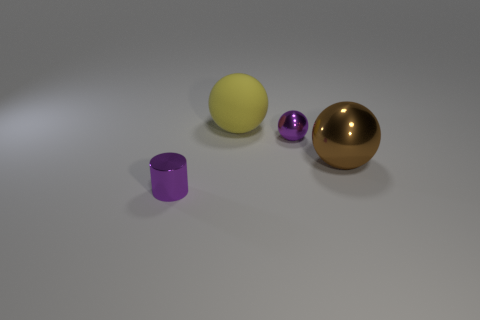Can you imagine what these objects could be used for in a real-world setting? The larger golden sphere could serve as a decorative piece or a paperweight, while the colorful cylinder and small ball might be components in a child's stacking toy set due to their size and apparent material. 